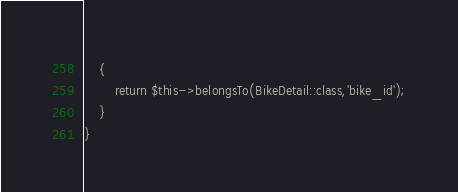Convert code to text. <code><loc_0><loc_0><loc_500><loc_500><_PHP_>    {
        return $this->belongsTo(BikeDetail::class,'bike_id');
    }
}
</code> 